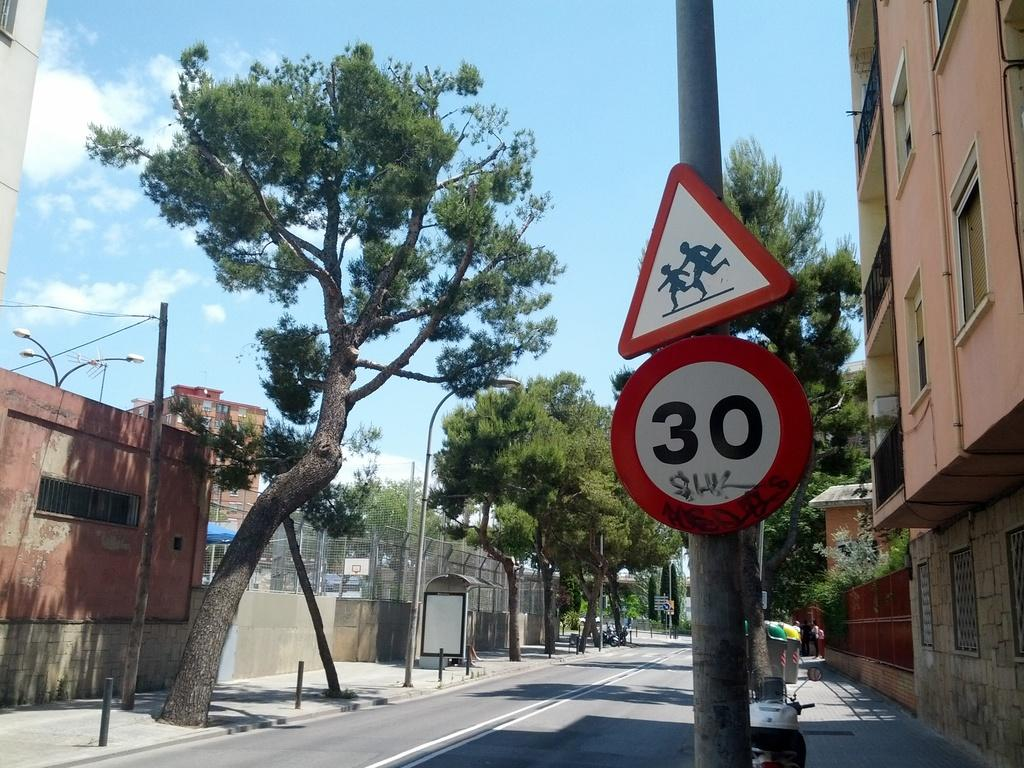Provide a one-sentence caption for the provided image. Below a triangular pedestrian sign is a circular one with the number 30 on it. 